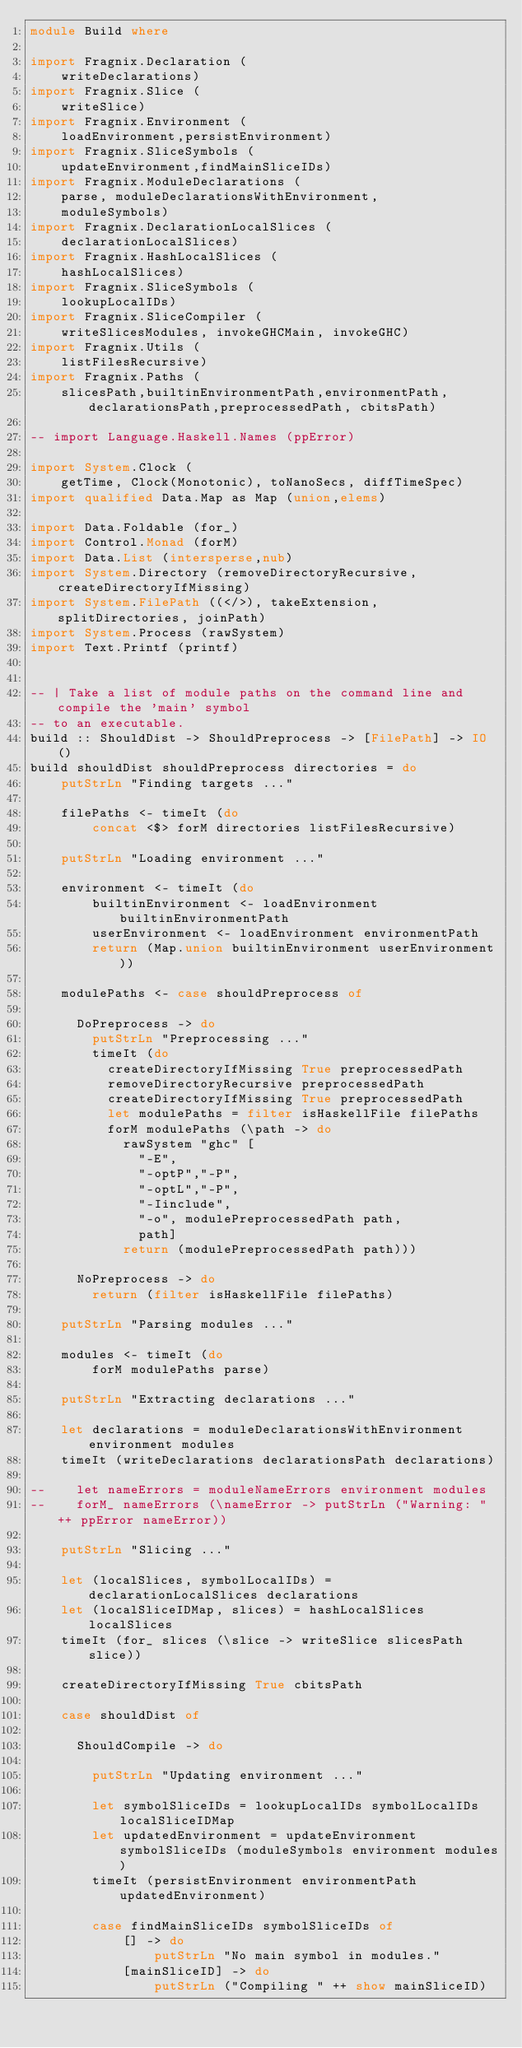Convert code to text. <code><loc_0><loc_0><loc_500><loc_500><_Haskell_>module Build where

import Fragnix.Declaration (
    writeDeclarations)
import Fragnix.Slice (
    writeSlice)
import Fragnix.Environment (
    loadEnvironment,persistEnvironment)
import Fragnix.SliceSymbols (
    updateEnvironment,findMainSliceIDs)
import Fragnix.ModuleDeclarations (
    parse, moduleDeclarationsWithEnvironment,
    moduleSymbols)
import Fragnix.DeclarationLocalSlices (
    declarationLocalSlices)
import Fragnix.HashLocalSlices (
    hashLocalSlices)
import Fragnix.SliceSymbols (
    lookupLocalIDs)
import Fragnix.SliceCompiler (
    writeSlicesModules, invokeGHCMain, invokeGHC)
import Fragnix.Utils (
    listFilesRecursive)
import Fragnix.Paths (
    slicesPath,builtinEnvironmentPath,environmentPath,declarationsPath,preprocessedPath, cbitsPath)

-- import Language.Haskell.Names (ppError)

import System.Clock (
    getTime, Clock(Monotonic), toNanoSecs, diffTimeSpec)
import qualified Data.Map as Map (union,elems)

import Data.Foldable (for_)
import Control.Monad (forM)
import Data.List (intersperse,nub)
import System.Directory (removeDirectoryRecursive, createDirectoryIfMissing)
import System.FilePath ((</>), takeExtension, splitDirectories, joinPath)
import System.Process (rawSystem)
import Text.Printf (printf)


-- | Take a list of module paths on the command line and compile the 'main' symbol
-- to an executable.
build :: ShouldDist -> ShouldPreprocess -> [FilePath] -> IO ()
build shouldDist shouldPreprocess directories = do
    putStrLn "Finding targets ..."

    filePaths <- timeIt (do
        concat <$> forM directories listFilesRecursive)

    putStrLn "Loading environment ..."

    environment <- timeIt (do
        builtinEnvironment <- loadEnvironment builtinEnvironmentPath
        userEnvironment <- loadEnvironment environmentPath
        return (Map.union builtinEnvironment userEnvironment))

    modulePaths <- case shouldPreprocess of

      DoPreprocess -> do
        putStrLn "Preprocessing ..."
        timeIt (do
          createDirectoryIfMissing True preprocessedPath
          removeDirectoryRecursive preprocessedPath
          createDirectoryIfMissing True preprocessedPath
          let modulePaths = filter isHaskellFile filePaths
          forM modulePaths (\path -> do
            rawSystem "ghc" [
              "-E",
              "-optP","-P",
              "-optL","-P",
              "-Iinclude",
              "-o", modulePreprocessedPath path,
              path]
            return (modulePreprocessedPath path)))

      NoPreprocess -> do
        return (filter isHaskellFile filePaths)

    putStrLn "Parsing modules ..."

    modules <- timeIt (do
        forM modulePaths parse)

    putStrLn "Extracting declarations ..."

    let declarations = moduleDeclarationsWithEnvironment environment modules
    timeIt (writeDeclarations declarationsPath declarations)

--    let nameErrors = moduleNameErrors environment modules
--    forM_ nameErrors (\nameError -> putStrLn ("Warning: " ++ ppError nameError))

    putStrLn "Slicing ..."

    let (localSlices, symbolLocalIDs) = declarationLocalSlices declarations
    let (localSliceIDMap, slices) = hashLocalSlices localSlices
    timeIt (for_ slices (\slice -> writeSlice slicesPath slice))

    createDirectoryIfMissing True cbitsPath

    case shouldDist of

      ShouldCompile -> do

        putStrLn "Updating environment ..."

        let symbolSliceIDs = lookupLocalIDs symbolLocalIDs localSliceIDMap
        let updatedEnvironment = updateEnvironment symbolSliceIDs (moduleSymbols environment modules)
        timeIt (persistEnvironment environmentPath updatedEnvironment)

        case findMainSliceIDs symbolSliceIDs of
            [] -> do
                putStrLn "No main symbol in modules."
            [mainSliceID] -> do
                putStrLn ("Compiling " ++ show mainSliceID)</code> 